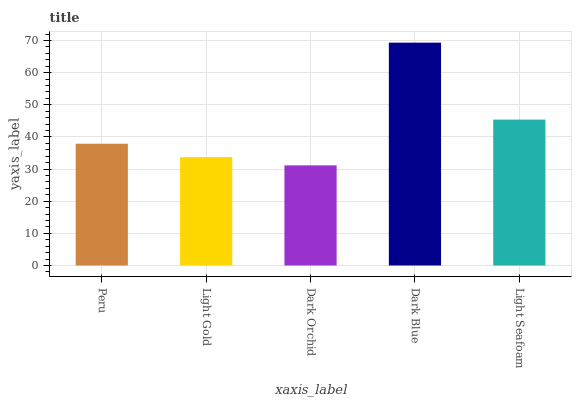Is Light Gold the minimum?
Answer yes or no. No. Is Light Gold the maximum?
Answer yes or no. No. Is Peru greater than Light Gold?
Answer yes or no. Yes. Is Light Gold less than Peru?
Answer yes or no. Yes. Is Light Gold greater than Peru?
Answer yes or no. No. Is Peru less than Light Gold?
Answer yes or no. No. Is Peru the high median?
Answer yes or no. Yes. Is Peru the low median?
Answer yes or no. Yes. Is Dark Blue the high median?
Answer yes or no. No. Is Light Seafoam the low median?
Answer yes or no. No. 